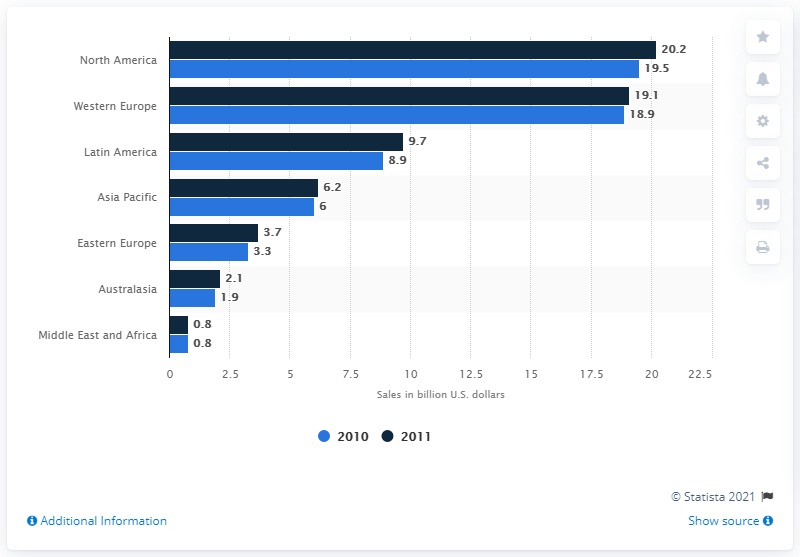Give some essential details in this illustration. In 2010, Eastern Europe had the highest sales growth, making it the region with the largest sales growth that year. In 2010, the sales of pet food in North America totaled 19.5 billion dollars. 